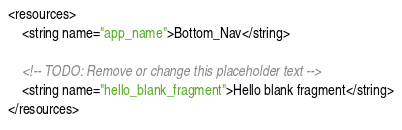<code> <loc_0><loc_0><loc_500><loc_500><_XML_><resources>
    <string name="app_name">Bottom_Nav</string>

    <!-- TODO: Remove or change this placeholder text -->
    <string name="hello_blank_fragment">Hello blank fragment</string>
</resources>
</code> 